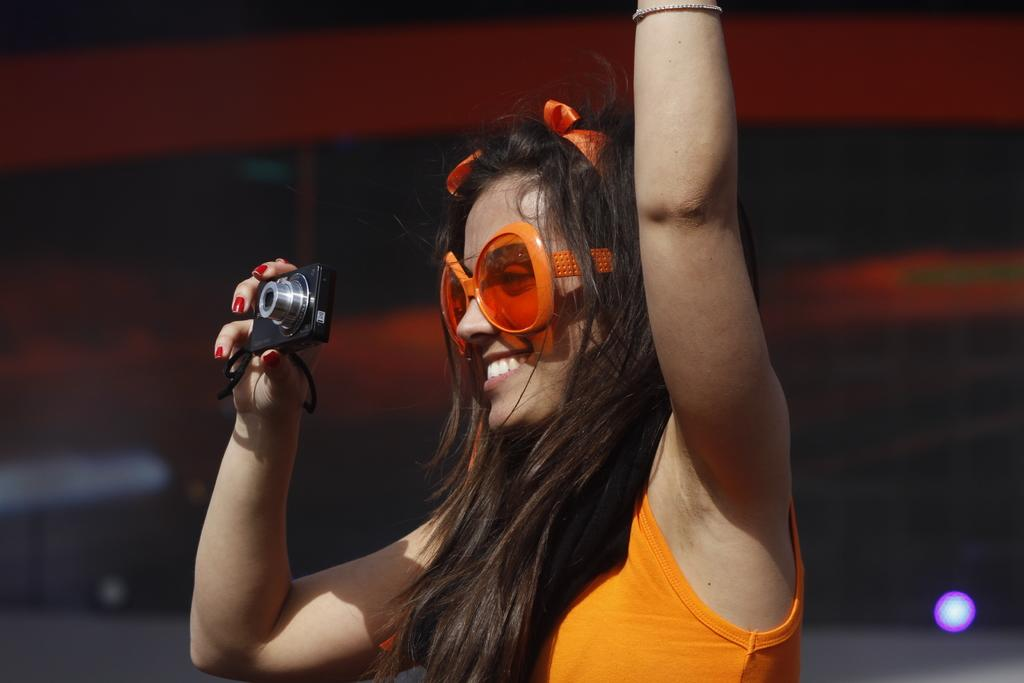Who is present in the image? There is a woman in the image. What is the woman wearing on her upper body? The woman is wearing an orange top. What type of eyewear is the woman wearing? The woman is wearing orange shades. What object is the woman holding in her hand? The woman is holding a camera in her hand. What type of basin can be seen in the image? There is no basin present in the image. How does the woman establish her territory in the image? The image does not depict any territorial behavior or markings, and the concept of territory is not applicable to this context. 